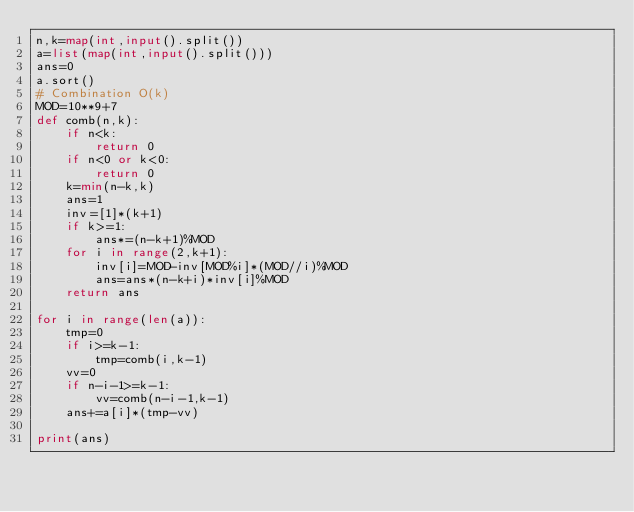<code> <loc_0><loc_0><loc_500><loc_500><_Python_>n,k=map(int,input().split())
a=list(map(int,input().split()))
ans=0
a.sort()
# Combination O(k)
MOD=10**9+7
def comb(n,k):
    if n<k:
        return 0
    if n<0 or k<0:
        return 0
    k=min(n-k,k)
    ans=1
    inv=[1]*(k+1)
    if k>=1:
        ans*=(n-k+1)%MOD
    for i in range(2,k+1):
        inv[i]=MOD-inv[MOD%i]*(MOD//i)%MOD
        ans=ans*(n-k+i)*inv[i]%MOD
    return ans

for i in range(len(a)):
    tmp=0
    if i>=k-1:
        tmp=comb(i,k-1)
    vv=0
    if n-i-1>=k-1:
        vv=comb(n-i-1,k-1)
    ans+=a[i]*(tmp-vv)

print(ans)</code> 